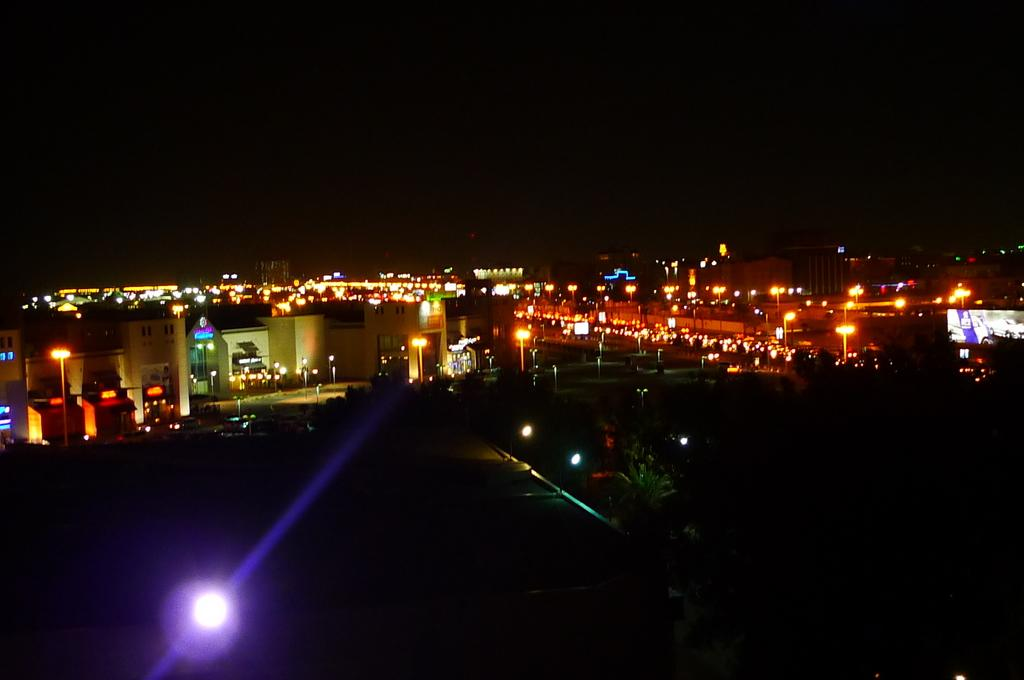What type of structures are present in the image? There are multiple buildings in the image. What else can be seen in the image besides the buildings? There are lights and trees visible in the image. How would you describe the lighting conditions in the image? The image appears to be in a dark setting. How many chickens are present in the image? There are no chickens present in the image. What type of wrist accessory is visible on the people in the image? There are no people visible in the image, so it is impossible to determine if there are any wrist accessories present. 